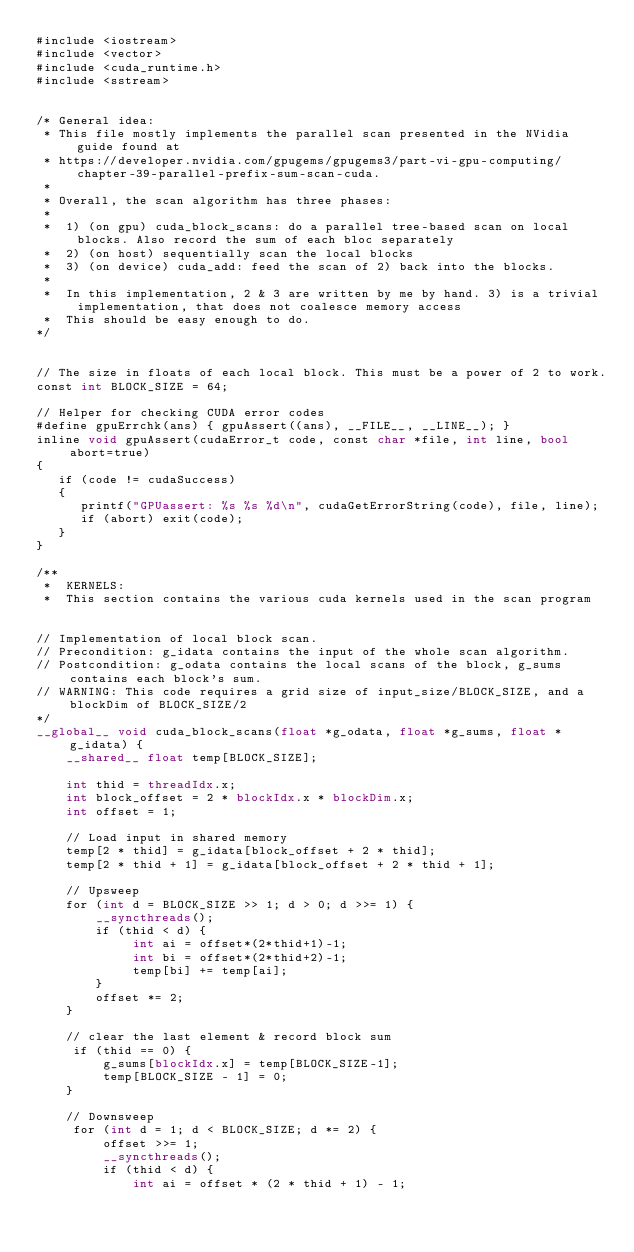Convert code to text. <code><loc_0><loc_0><loc_500><loc_500><_Cuda_>#include <iostream>
#include <vector>
#include <cuda_runtime.h>
#include <sstream> 


/* General idea:
 * This file mostly implements the parallel scan presented in the NVidia guide found at
 * https://developer.nvidia.com/gpugems/gpugems3/part-vi-gpu-computing/chapter-39-parallel-prefix-sum-scan-cuda.
 * 
 * Overall, the scan algorithm has three phases:
 * 
 *  1) (on gpu) cuda_block_scans: do a parallel tree-based scan on local blocks. Also record the sum of each bloc separately
 *  2) (on host) sequentially scan the local blocks
 *  3) (on device) cuda_add: feed the scan of 2) back into the blocks.
 * 
 *  In this implementation, 2 & 3 are written by me by hand. 3) is a trivial implementation, that does not coalesce memory access
 *  This should be easy enough to do.
*/


// The size in floats of each local block. This must be a power of 2 to work.
const int BLOCK_SIZE = 64;

// Helper for checking CUDA error codes
#define gpuErrchk(ans) { gpuAssert((ans), __FILE__, __LINE__); }
inline void gpuAssert(cudaError_t code, const char *file, int line, bool abort=true)
{
   if (code != cudaSuccess) 
   {
      printf("GPUassert: %s %s %d\n", cudaGetErrorString(code), file, line);
      if (abort) exit(code);
   }
}

/**
 *  KERNELS:
 *  This section contains the various cuda kernels used in the scan program


// Implementation of local block scan.
// Precondition: g_idata contains the input of the whole scan algorithm.
// Postcondition: g_odata contains the local scans of the block, g_sums contains each block's sum.
// WARNING: This code requires a grid size of input_size/BLOCK_SIZE, and a blockDim of BLOCK_SIZE/2
*/
__global__ void cuda_block_scans(float *g_odata, float *g_sums, float *g_idata) {
    __shared__ float temp[BLOCK_SIZE];

    int thid = threadIdx.x;
    int block_offset = 2 * blockIdx.x * blockDim.x;
    int offset = 1;

    // Load input in shared memory
    temp[2 * thid] = g_idata[block_offset + 2 * thid];
    temp[2 * thid + 1] = g_idata[block_offset + 2 * thid + 1];

    // Upsweep
    for (int d = BLOCK_SIZE >> 1; d > 0; d >>= 1) {
        __syncthreads();
        if (thid < d) {
             int ai = offset*(2*thid+1)-1;     
             int bi = offset*(2*thid+2)-1;
             temp[bi] += temp[ai];
        }
        offset *= 2;
    }

    // clear the last element & record block sum
     if (thid == 0) {
         g_sums[blockIdx.x] = temp[BLOCK_SIZE-1];
         temp[BLOCK_SIZE - 1] = 0; 
    }

    // Downsweep
     for (int d = 1; d < BLOCK_SIZE; d *= 2) {
         offset >>= 1;
         __syncthreads();
         if (thid < d) {
             int ai = offset * (2 * thid + 1) - 1;</code> 